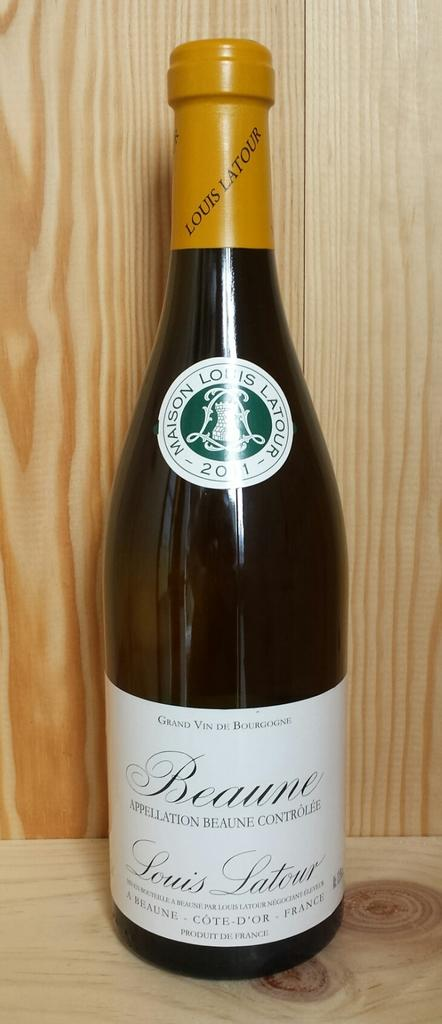Provide a one-sentence caption for the provided image. A bottle of Beaune French wine is prominently displayed. 